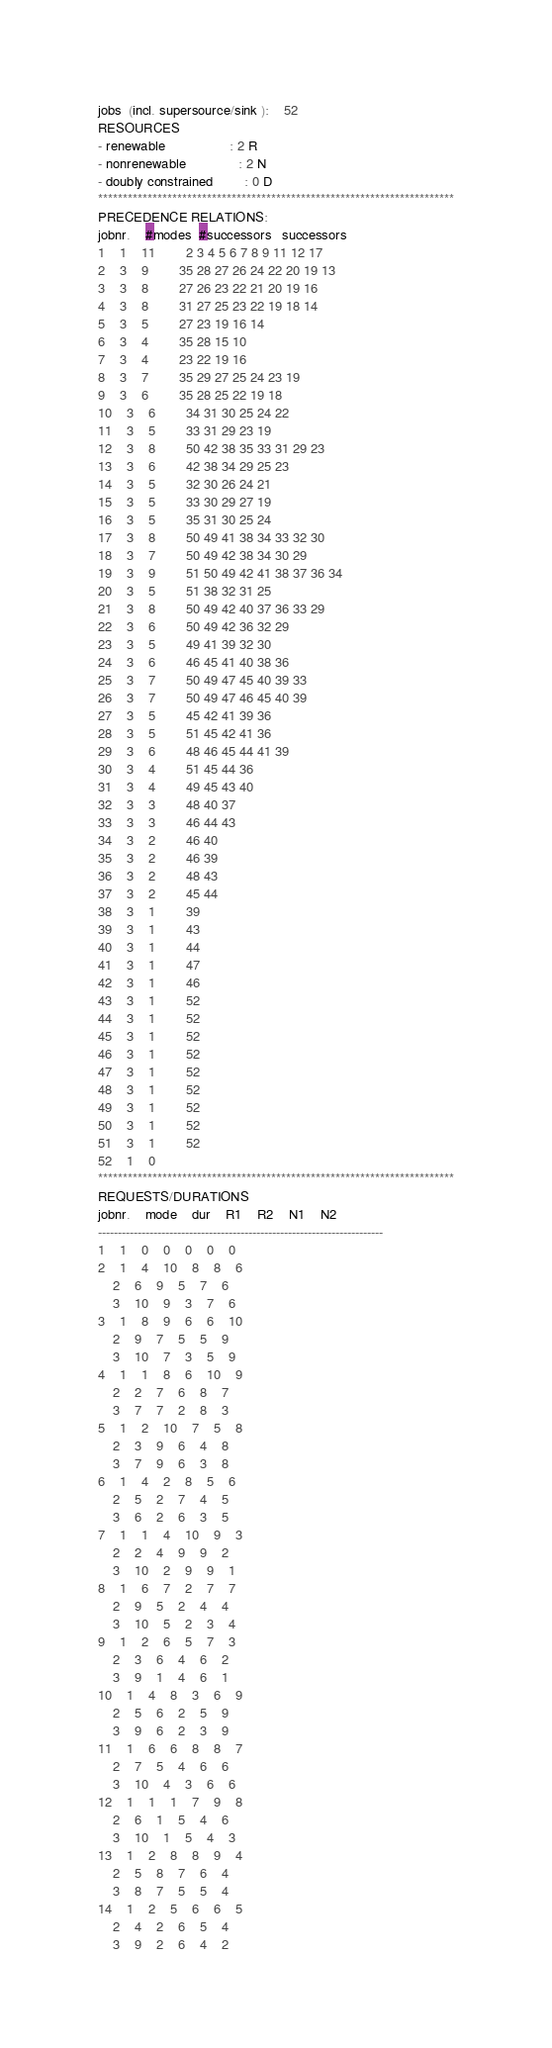Convert code to text. <code><loc_0><loc_0><loc_500><loc_500><_ObjectiveC_>jobs  (incl. supersource/sink ):	52
RESOURCES
- renewable                 : 2 R
- nonrenewable              : 2 N
- doubly constrained        : 0 D
************************************************************************
PRECEDENCE RELATIONS:
jobnr.    #modes  #successors   successors
1	1	11		2 3 4 5 6 7 8 9 11 12 17 
2	3	9		35 28 27 26 24 22 20 19 13 
3	3	8		27 26 23 22 21 20 19 16 
4	3	8		31 27 25 23 22 19 18 14 
5	3	5		27 23 19 16 14 
6	3	4		35 28 15 10 
7	3	4		23 22 19 16 
8	3	7		35 29 27 25 24 23 19 
9	3	6		35 28 25 22 19 18 
10	3	6		34 31 30 25 24 22 
11	3	5		33 31 29 23 19 
12	3	8		50 42 38 35 33 31 29 23 
13	3	6		42 38 34 29 25 23 
14	3	5		32 30 26 24 21 
15	3	5		33 30 29 27 19 
16	3	5		35 31 30 25 24 
17	3	8		50 49 41 38 34 33 32 30 
18	3	7		50 49 42 38 34 30 29 
19	3	9		51 50 49 42 41 38 37 36 34 
20	3	5		51 38 32 31 25 
21	3	8		50 49 42 40 37 36 33 29 
22	3	6		50 49 42 36 32 29 
23	3	5		49 41 39 32 30 
24	3	6		46 45 41 40 38 36 
25	3	7		50 49 47 45 40 39 33 
26	3	7		50 49 47 46 45 40 39 
27	3	5		45 42 41 39 36 
28	3	5		51 45 42 41 36 
29	3	6		48 46 45 44 41 39 
30	3	4		51 45 44 36 
31	3	4		49 45 43 40 
32	3	3		48 40 37 
33	3	3		46 44 43 
34	3	2		46 40 
35	3	2		46 39 
36	3	2		48 43 
37	3	2		45 44 
38	3	1		39 
39	3	1		43 
40	3	1		44 
41	3	1		47 
42	3	1		46 
43	3	1		52 
44	3	1		52 
45	3	1		52 
46	3	1		52 
47	3	1		52 
48	3	1		52 
49	3	1		52 
50	3	1		52 
51	3	1		52 
52	1	0		
************************************************************************
REQUESTS/DURATIONS
jobnr.	mode	dur	R1	R2	N1	N2	
------------------------------------------------------------------------
1	1	0	0	0	0	0	
2	1	4	10	8	8	6	
	2	6	9	5	7	6	
	3	10	9	3	7	6	
3	1	8	9	6	6	10	
	2	9	7	5	5	9	
	3	10	7	3	5	9	
4	1	1	8	6	10	9	
	2	2	7	6	8	7	
	3	7	7	2	8	3	
5	1	2	10	7	5	8	
	2	3	9	6	4	8	
	3	7	9	6	3	8	
6	1	4	2	8	5	6	
	2	5	2	7	4	5	
	3	6	2	6	3	5	
7	1	1	4	10	9	3	
	2	2	4	9	9	2	
	3	10	2	9	9	1	
8	1	6	7	2	7	7	
	2	9	5	2	4	4	
	3	10	5	2	3	4	
9	1	2	6	5	7	3	
	2	3	6	4	6	2	
	3	9	1	4	6	1	
10	1	4	8	3	6	9	
	2	5	6	2	5	9	
	3	9	6	2	3	9	
11	1	6	6	8	8	7	
	2	7	5	4	6	6	
	3	10	4	3	6	6	
12	1	1	1	7	9	8	
	2	6	1	5	4	6	
	3	10	1	5	4	3	
13	1	2	8	8	9	4	
	2	5	8	7	6	4	
	3	8	7	5	5	4	
14	1	2	5	6	6	5	
	2	4	2	6	5	4	
	3	9	2	6	4	2	</code> 